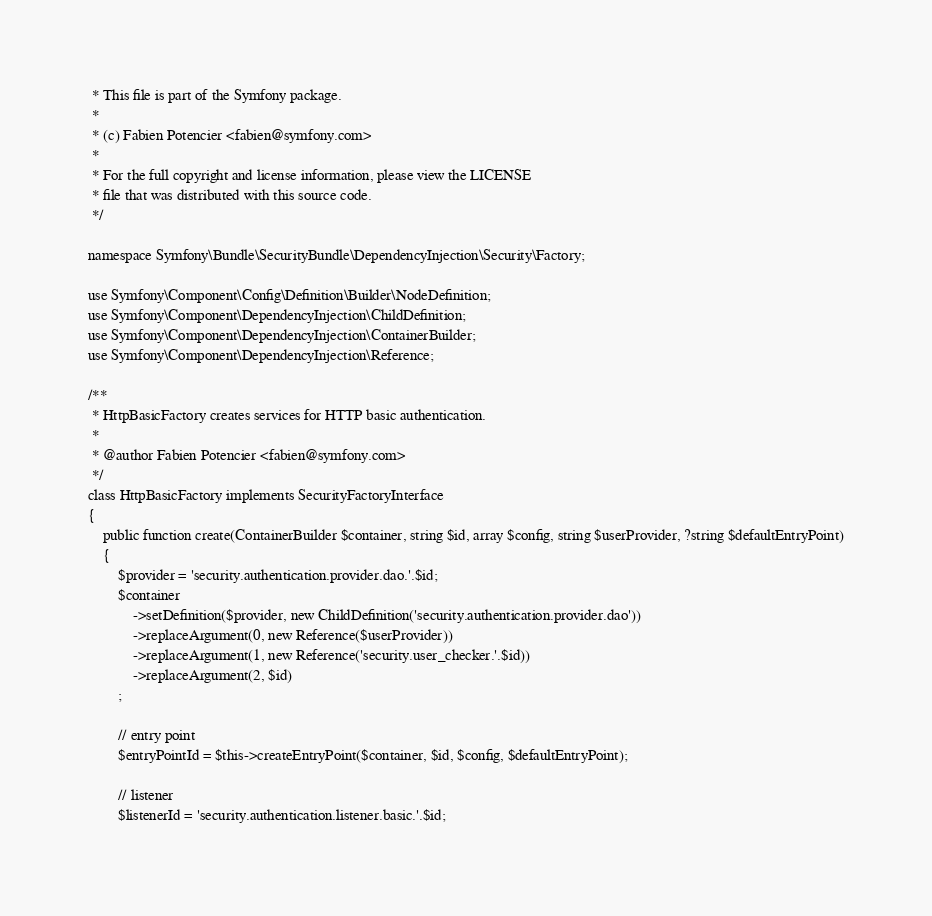Convert code to text. <code><loc_0><loc_0><loc_500><loc_500><_PHP_> * This file is part of the Symfony package.
 *
 * (c) Fabien Potencier <fabien@symfony.com>
 *
 * For the full copyright and license information, please view the LICENSE
 * file that was distributed with this source code.
 */

namespace Symfony\Bundle\SecurityBundle\DependencyInjection\Security\Factory;

use Symfony\Component\Config\Definition\Builder\NodeDefinition;
use Symfony\Component\DependencyInjection\ChildDefinition;
use Symfony\Component\DependencyInjection\ContainerBuilder;
use Symfony\Component\DependencyInjection\Reference;

/**
 * HttpBasicFactory creates services for HTTP basic authentication.
 *
 * @author Fabien Potencier <fabien@symfony.com>
 */
class HttpBasicFactory implements SecurityFactoryInterface
{
    public function create(ContainerBuilder $container, string $id, array $config, string $userProvider, ?string $defaultEntryPoint)
    {
        $provider = 'security.authentication.provider.dao.'.$id;
        $container
            ->setDefinition($provider, new ChildDefinition('security.authentication.provider.dao'))
            ->replaceArgument(0, new Reference($userProvider))
            ->replaceArgument(1, new Reference('security.user_checker.'.$id))
            ->replaceArgument(2, $id)
        ;

        // entry point
        $entryPointId = $this->createEntryPoint($container, $id, $config, $defaultEntryPoint);

        // listener
        $listenerId = 'security.authentication.listener.basic.'.$id;</code> 